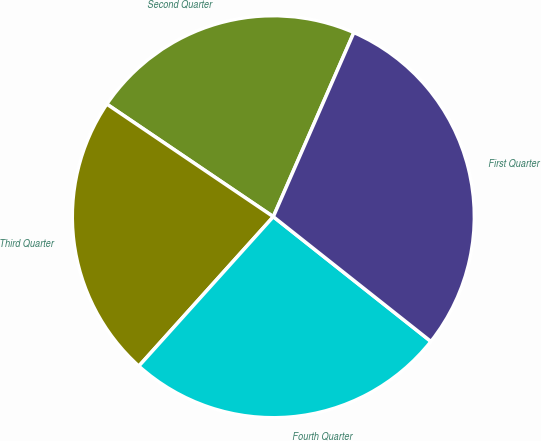Convert chart. <chart><loc_0><loc_0><loc_500><loc_500><pie_chart><fcel>Second Quarter<fcel>Third Quarter<fcel>Fourth Quarter<fcel>First Quarter<nl><fcel>22.1%<fcel>22.8%<fcel>26.01%<fcel>29.1%<nl></chart> 